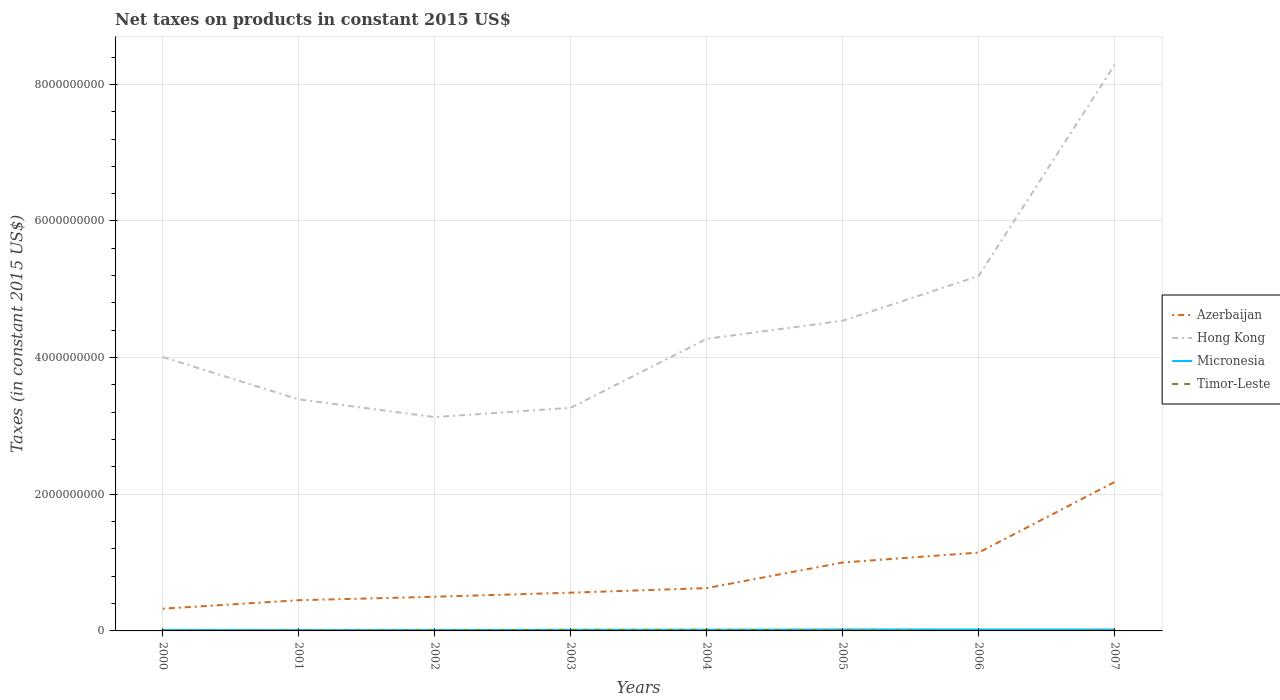How many different coloured lines are there?
Provide a succinct answer. 4. Is the number of lines equal to the number of legend labels?
Give a very brief answer. No. What is the total net taxes on products in Micronesia in the graph?
Your response must be concise. -6.44e+06. What is the difference between the highest and the second highest net taxes on products in Azerbaijan?
Keep it short and to the point. 1.85e+09. What is the difference between the highest and the lowest net taxes on products in Timor-Leste?
Your answer should be very brief. 4. Is the net taxes on products in Timor-Leste strictly greater than the net taxes on products in Hong Kong over the years?
Your answer should be compact. Yes. How many years are there in the graph?
Provide a succinct answer. 8. What is the difference between two consecutive major ticks on the Y-axis?
Provide a short and direct response. 2.00e+09. Are the values on the major ticks of Y-axis written in scientific E-notation?
Offer a terse response. No. Does the graph contain grids?
Your response must be concise. Yes. How many legend labels are there?
Provide a short and direct response. 4. What is the title of the graph?
Ensure brevity in your answer.  Net taxes on products in constant 2015 US$. What is the label or title of the Y-axis?
Keep it short and to the point. Taxes (in constant 2015 US$). What is the Taxes (in constant 2015 US$) of Azerbaijan in 2000?
Offer a terse response. 3.25e+08. What is the Taxes (in constant 2015 US$) in Hong Kong in 2000?
Make the answer very short. 4.01e+09. What is the Taxes (in constant 2015 US$) in Micronesia in 2000?
Give a very brief answer. 1.47e+07. What is the Taxes (in constant 2015 US$) of Timor-Leste in 2000?
Provide a short and direct response. 5.00e+06. What is the Taxes (in constant 2015 US$) of Azerbaijan in 2001?
Give a very brief answer. 4.49e+08. What is the Taxes (in constant 2015 US$) of Hong Kong in 2001?
Ensure brevity in your answer.  3.39e+09. What is the Taxes (in constant 2015 US$) in Micronesia in 2001?
Offer a very short reply. 1.35e+07. What is the Taxes (in constant 2015 US$) in Timor-Leste in 2001?
Keep it short and to the point. 8.00e+06. What is the Taxes (in constant 2015 US$) of Azerbaijan in 2002?
Your answer should be compact. 5.00e+08. What is the Taxes (in constant 2015 US$) in Hong Kong in 2002?
Ensure brevity in your answer.  3.13e+09. What is the Taxes (in constant 2015 US$) in Micronesia in 2002?
Your answer should be compact. 1.42e+07. What is the Taxes (in constant 2015 US$) of Azerbaijan in 2003?
Ensure brevity in your answer.  5.60e+08. What is the Taxes (in constant 2015 US$) in Hong Kong in 2003?
Your response must be concise. 3.27e+09. What is the Taxes (in constant 2015 US$) of Micronesia in 2003?
Ensure brevity in your answer.  1.67e+07. What is the Taxes (in constant 2015 US$) in Timor-Leste in 2003?
Your answer should be very brief. 1.50e+07. What is the Taxes (in constant 2015 US$) in Azerbaijan in 2004?
Ensure brevity in your answer.  6.27e+08. What is the Taxes (in constant 2015 US$) of Hong Kong in 2004?
Your answer should be very brief. 4.28e+09. What is the Taxes (in constant 2015 US$) in Micronesia in 2004?
Your answer should be very brief. 1.77e+07. What is the Taxes (in constant 2015 US$) in Timor-Leste in 2004?
Offer a very short reply. 1.60e+07. What is the Taxes (in constant 2015 US$) of Azerbaijan in 2005?
Your response must be concise. 1.00e+09. What is the Taxes (in constant 2015 US$) in Hong Kong in 2005?
Ensure brevity in your answer.  4.54e+09. What is the Taxes (in constant 2015 US$) of Micronesia in 2005?
Your answer should be compact. 2.14e+07. What is the Taxes (in constant 2015 US$) in Timor-Leste in 2005?
Offer a terse response. 1.20e+07. What is the Taxes (in constant 2015 US$) in Azerbaijan in 2006?
Give a very brief answer. 1.15e+09. What is the Taxes (in constant 2015 US$) in Hong Kong in 2006?
Your answer should be compact. 5.19e+09. What is the Taxes (in constant 2015 US$) of Micronesia in 2006?
Give a very brief answer. 2.11e+07. What is the Taxes (in constant 2015 US$) in Timor-Leste in 2006?
Provide a short and direct response. 0. What is the Taxes (in constant 2015 US$) in Azerbaijan in 2007?
Your answer should be compact. 2.18e+09. What is the Taxes (in constant 2015 US$) of Hong Kong in 2007?
Provide a succinct answer. 8.28e+09. What is the Taxes (in constant 2015 US$) in Micronesia in 2007?
Ensure brevity in your answer.  2.04e+07. What is the Taxes (in constant 2015 US$) in Timor-Leste in 2007?
Your answer should be compact. 9.00e+06. Across all years, what is the maximum Taxes (in constant 2015 US$) in Azerbaijan?
Your answer should be compact. 2.18e+09. Across all years, what is the maximum Taxes (in constant 2015 US$) in Hong Kong?
Give a very brief answer. 8.28e+09. Across all years, what is the maximum Taxes (in constant 2015 US$) of Micronesia?
Give a very brief answer. 2.14e+07. Across all years, what is the maximum Taxes (in constant 2015 US$) in Timor-Leste?
Your response must be concise. 1.60e+07. Across all years, what is the minimum Taxes (in constant 2015 US$) in Azerbaijan?
Your response must be concise. 3.25e+08. Across all years, what is the minimum Taxes (in constant 2015 US$) of Hong Kong?
Offer a terse response. 3.13e+09. Across all years, what is the minimum Taxes (in constant 2015 US$) in Micronesia?
Ensure brevity in your answer.  1.35e+07. Across all years, what is the minimum Taxes (in constant 2015 US$) of Timor-Leste?
Keep it short and to the point. 0. What is the total Taxes (in constant 2015 US$) of Azerbaijan in the graph?
Provide a succinct answer. 6.79e+09. What is the total Taxes (in constant 2015 US$) of Hong Kong in the graph?
Provide a short and direct response. 3.61e+1. What is the total Taxes (in constant 2015 US$) of Micronesia in the graph?
Ensure brevity in your answer.  1.40e+08. What is the total Taxes (in constant 2015 US$) of Timor-Leste in the graph?
Make the answer very short. 7.70e+07. What is the difference between the Taxes (in constant 2015 US$) in Azerbaijan in 2000 and that in 2001?
Keep it short and to the point. -1.24e+08. What is the difference between the Taxes (in constant 2015 US$) in Hong Kong in 2000 and that in 2001?
Ensure brevity in your answer.  6.19e+08. What is the difference between the Taxes (in constant 2015 US$) of Micronesia in 2000 and that in 2001?
Your answer should be very brief. 1.18e+06. What is the difference between the Taxes (in constant 2015 US$) in Timor-Leste in 2000 and that in 2001?
Offer a very short reply. -3.00e+06. What is the difference between the Taxes (in constant 2015 US$) in Azerbaijan in 2000 and that in 2002?
Offer a very short reply. -1.75e+08. What is the difference between the Taxes (in constant 2015 US$) of Hong Kong in 2000 and that in 2002?
Your answer should be compact. 8.79e+08. What is the difference between the Taxes (in constant 2015 US$) in Micronesia in 2000 and that in 2002?
Give a very brief answer. 4.29e+05. What is the difference between the Taxes (in constant 2015 US$) in Timor-Leste in 2000 and that in 2002?
Your answer should be compact. -7.00e+06. What is the difference between the Taxes (in constant 2015 US$) in Azerbaijan in 2000 and that in 2003?
Provide a short and direct response. -2.34e+08. What is the difference between the Taxes (in constant 2015 US$) in Hong Kong in 2000 and that in 2003?
Your answer should be very brief. 7.43e+08. What is the difference between the Taxes (in constant 2015 US$) in Micronesia in 2000 and that in 2003?
Your answer should be very brief. -2.08e+06. What is the difference between the Taxes (in constant 2015 US$) of Timor-Leste in 2000 and that in 2003?
Your response must be concise. -1.00e+07. What is the difference between the Taxes (in constant 2015 US$) in Azerbaijan in 2000 and that in 2004?
Your answer should be very brief. -3.01e+08. What is the difference between the Taxes (in constant 2015 US$) of Hong Kong in 2000 and that in 2004?
Offer a very short reply. -2.67e+08. What is the difference between the Taxes (in constant 2015 US$) of Micronesia in 2000 and that in 2004?
Make the answer very short. -3.07e+06. What is the difference between the Taxes (in constant 2015 US$) of Timor-Leste in 2000 and that in 2004?
Offer a terse response. -1.10e+07. What is the difference between the Taxes (in constant 2015 US$) of Azerbaijan in 2000 and that in 2005?
Your answer should be compact. -6.76e+08. What is the difference between the Taxes (in constant 2015 US$) of Hong Kong in 2000 and that in 2005?
Offer a very short reply. -5.31e+08. What is the difference between the Taxes (in constant 2015 US$) of Micronesia in 2000 and that in 2005?
Ensure brevity in your answer.  -6.70e+06. What is the difference between the Taxes (in constant 2015 US$) in Timor-Leste in 2000 and that in 2005?
Make the answer very short. -7.00e+06. What is the difference between the Taxes (in constant 2015 US$) of Azerbaijan in 2000 and that in 2006?
Keep it short and to the point. -8.21e+08. What is the difference between the Taxes (in constant 2015 US$) of Hong Kong in 2000 and that in 2006?
Keep it short and to the point. -1.19e+09. What is the difference between the Taxes (in constant 2015 US$) of Micronesia in 2000 and that in 2006?
Give a very brief answer. -6.44e+06. What is the difference between the Taxes (in constant 2015 US$) of Azerbaijan in 2000 and that in 2007?
Provide a short and direct response. -1.85e+09. What is the difference between the Taxes (in constant 2015 US$) in Hong Kong in 2000 and that in 2007?
Ensure brevity in your answer.  -4.28e+09. What is the difference between the Taxes (in constant 2015 US$) in Micronesia in 2000 and that in 2007?
Your answer should be compact. -5.76e+06. What is the difference between the Taxes (in constant 2015 US$) in Azerbaijan in 2001 and that in 2002?
Your response must be concise. -5.09e+07. What is the difference between the Taxes (in constant 2015 US$) of Hong Kong in 2001 and that in 2002?
Your answer should be very brief. 2.60e+08. What is the difference between the Taxes (in constant 2015 US$) in Micronesia in 2001 and that in 2002?
Offer a very short reply. -7.48e+05. What is the difference between the Taxes (in constant 2015 US$) of Azerbaijan in 2001 and that in 2003?
Offer a terse response. -1.10e+08. What is the difference between the Taxes (in constant 2015 US$) of Hong Kong in 2001 and that in 2003?
Offer a terse response. 1.24e+08. What is the difference between the Taxes (in constant 2015 US$) in Micronesia in 2001 and that in 2003?
Provide a short and direct response. -3.26e+06. What is the difference between the Taxes (in constant 2015 US$) in Timor-Leste in 2001 and that in 2003?
Your answer should be very brief. -7.00e+06. What is the difference between the Taxes (in constant 2015 US$) in Azerbaijan in 2001 and that in 2004?
Provide a short and direct response. -1.77e+08. What is the difference between the Taxes (in constant 2015 US$) in Hong Kong in 2001 and that in 2004?
Your answer should be compact. -8.86e+08. What is the difference between the Taxes (in constant 2015 US$) in Micronesia in 2001 and that in 2004?
Offer a terse response. -4.25e+06. What is the difference between the Taxes (in constant 2015 US$) of Timor-Leste in 2001 and that in 2004?
Ensure brevity in your answer.  -8.00e+06. What is the difference between the Taxes (in constant 2015 US$) in Azerbaijan in 2001 and that in 2005?
Your response must be concise. -5.52e+08. What is the difference between the Taxes (in constant 2015 US$) in Hong Kong in 2001 and that in 2005?
Keep it short and to the point. -1.15e+09. What is the difference between the Taxes (in constant 2015 US$) of Micronesia in 2001 and that in 2005?
Offer a very short reply. -7.88e+06. What is the difference between the Taxes (in constant 2015 US$) of Azerbaijan in 2001 and that in 2006?
Give a very brief answer. -6.97e+08. What is the difference between the Taxes (in constant 2015 US$) in Hong Kong in 2001 and that in 2006?
Keep it short and to the point. -1.80e+09. What is the difference between the Taxes (in constant 2015 US$) of Micronesia in 2001 and that in 2006?
Offer a very short reply. -7.62e+06. What is the difference between the Taxes (in constant 2015 US$) in Azerbaijan in 2001 and that in 2007?
Give a very brief answer. -1.73e+09. What is the difference between the Taxes (in constant 2015 US$) in Hong Kong in 2001 and that in 2007?
Offer a terse response. -4.90e+09. What is the difference between the Taxes (in constant 2015 US$) in Micronesia in 2001 and that in 2007?
Ensure brevity in your answer.  -6.93e+06. What is the difference between the Taxes (in constant 2015 US$) in Azerbaijan in 2002 and that in 2003?
Make the answer very short. -5.95e+07. What is the difference between the Taxes (in constant 2015 US$) of Hong Kong in 2002 and that in 2003?
Ensure brevity in your answer.  -1.36e+08. What is the difference between the Taxes (in constant 2015 US$) of Micronesia in 2002 and that in 2003?
Provide a succinct answer. -2.51e+06. What is the difference between the Taxes (in constant 2015 US$) of Azerbaijan in 2002 and that in 2004?
Keep it short and to the point. -1.26e+08. What is the difference between the Taxes (in constant 2015 US$) in Hong Kong in 2002 and that in 2004?
Your answer should be very brief. -1.15e+09. What is the difference between the Taxes (in constant 2015 US$) of Micronesia in 2002 and that in 2004?
Make the answer very short. -3.50e+06. What is the difference between the Taxes (in constant 2015 US$) in Timor-Leste in 2002 and that in 2004?
Provide a succinct answer. -4.00e+06. What is the difference between the Taxes (in constant 2015 US$) in Azerbaijan in 2002 and that in 2005?
Provide a short and direct response. -5.01e+08. What is the difference between the Taxes (in constant 2015 US$) of Hong Kong in 2002 and that in 2005?
Your answer should be very brief. -1.41e+09. What is the difference between the Taxes (in constant 2015 US$) of Micronesia in 2002 and that in 2005?
Give a very brief answer. -7.13e+06. What is the difference between the Taxes (in constant 2015 US$) of Timor-Leste in 2002 and that in 2005?
Your answer should be very brief. 0. What is the difference between the Taxes (in constant 2015 US$) of Azerbaijan in 2002 and that in 2006?
Ensure brevity in your answer.  -6.46e+08. What is the difference between the Taxes (in constant 2015 US$) of Hong Kong in 2002 and that in 2006?
Keep it short and to the point. -2.06e+09. What is the difference between the Taxes (in constant 2015 US$) of Micronesia in 2002 and that in 2006?
Offer a very short reply. -6.87e+06. What is the difference between the Taxes (in constant 2015 US$) in Azerbaijan in 2002 and that in 2007?
Offer a very short reply. -1.68e+09. What is the difference between the Taxes (in constant 2015 US$) of Hong Kong in 2002 and that in 2007?
Your response must be concise. -5.16e+09. What is the difference between the Taxes (in constant 2015 US$) of Micronesia in 2002 and that in 2007?
Ensure brevity in your answer.  -6.18e+06. What is the difference between the Taxes (in constant 2015 US$) in Azerbaijan in 2003 and that in 2004?
Provide a short and direct response. -6.69e+07. What is the difference between the Taxes (in constant 2015 US$) in Hong Kong in 2003 and that in 2004?
Keep it short and to the point. -1.01e+09. What is the difference between the Taxes (in constant 2015 US$) in Micronesia in 2003 and that in 2004?
Make the answer very short. -9.89e+05. What is the difference between the Taxes (in constant 2015 US$) in Azerbaijan in 2003 and that in 2005?
Provide a succinct answer. -4.41e+08. What is the difference between the Taxes (in constant 2015 US$) of Hong Kong in 2003 and that in 2005?
Keep it short and to the point. -1.27e+09. What is the difference between the Taxes (in constant 2015 US$) in Micronesia in 2003 and that in 2005?
Ensure brevity in your answer.  -4.62e+06. What is the difference between the Taxes (in constant 2015 US$) of Timor-Leste in 2003 and that in 2005?
Ensure brevity in your answer.  3.00e+06. What is the difference between the Taxes (in constant 2015 US$) in Azerbaijan in 2003 and that in 2006?
Keep it short and to the point. -5.87e+08. What is the difference between the Taxes (in constant 2015 US$) of Hong Kong in 2003 and that in 2006?
Provide a short and direct response. -1.93e+09. What is the difference between the Taxes (in constant 2015 US$) of Micronesia in 2003 and that in 2006?
Your answer should be very brief. -4.36e+06. What is the difference between the Taxes (in constant 2015 US$) in Azerbaijan in 2003 and that in 2007?
Offer a very short reply. -1.62e+09. What is the difference between the Taxes (in constant 2015 US$) in Hong Kong in 2003 and that in 2007?
Ensure brevity in your answer.  -5.02e+09. What is the difference between the Taxes (in constant 2015 US$) in Micronesia in 2003 and that in 2007?
Ensure brevity in your answer.  -3.68e+06. What is the difference between the Taxes (in constant 2015 US$) of Timor-Leste in 2003 and that in 2007?
Provide a short and direct response. 6.00e+06. What is the difference between the Taxes (in constant 2015 US$) of Azerbaijan in 2004 and that in 2005?
Your response must be concise. -3.75e+08. What is the difference between the Taxes (in constant 2015 US$) of Hong Kong in 2004 and that in 2005?
Give a very brief answer. -2.64e+08. What is the difference between the Taxes (in constant 2015 US$) of Micronesia in 2004 and that in 2005?
Offer a very short reply. -3.63e+06. What is the difference between the Taxes (in constant 2015 US$) of Timor-Leste in 2004 and that in 2005?
Keep it short and to the point. 4.00e+06. What is the difference between the Taxes (in constant 2015 US$) in Azerbaijan in 2004 and that in 2006?
Keep it short and to the point. -5.20e+08. What is the difference between the Taxes (in constant 2015 US$) of Hong Kong in 2004 and that in 2006?
Offer a very short reply. -9.19e+08. What is the difference between the Taxes (in constant 2015 US$) in Micronesia in 2004 and that in 2006?
Provide a short and direct response. -3.38e+06. What is the difference between the Taxes (in constant 2015 US$) of Azerbaijan in 2004 and that in 2007?
Offer a terse response. -1.55e+09. What is the difference between the Taxes (in constant 2015 US$) of Hong Kong in 2004 and that in 2007?
Give a very brief answer. -4.01e+09. What is the difference between the Taxes (in constant 2015 US$) of Micronesia in 2004 and that in 2007?
Provide a succinct answer. -2.69e+06. What is the difference between the Taxes (in constant 2015 US$) of Timor-Leste in 2004 and that in 2007?
Your answer should be very brief. 7.00e+06. What is the difference between the Taxes (in constant 2015 US$) of Azerbaijan in 2005 and that in 2006?
Provide a succinct answer. -1.45e+08. What is the difference between the Taxes (in constant 2015 US$) of Hong Kong in 2005 and that in 2006?
Give a very brief answer. -6.55e+08. What is the difference between the Taxes (in constant 2015 US$) of Micronesia in 2005 and that in 2006?
Provide a succinct answer. 2.57e+05. What is the difference between the Taxes (in constant 2015 US$) of Azerbaijan in 2005 and that in 2007?
Provide a short and direct response. -1.18e+09. What is the difference between the Taxes (in constant 2015 US$) of Hong Kong in 2005 and that in 2007?
Offer a very short reply. -3.75e+09. What is the difference between the Taxes (in constant 2015 US$) in Micronesia in 2005 and that in 2007?
Provide a succinct answer. 9.44e+05. What is the difference between the Taxes (in constant 2015 US$) of Azerbaijan in 2006 and that in 2007?
Your answer should be compact. -1.03e+09. What is the difference between the Taxes (in constant 2015 US$) in Hong Kong in 2006 and that in 2007?
Ensure brevity in your answer.  -3.09e+09. What is the difference between the Taxes (in constant 2015 US$) of Micronesia in 2006 and that in 2007?
Your answer should be very brief. 6.88e+05. What is the difference between the Taxes (in constant 2015 US$) of Azerbaijan in 2000 and the Taxes (in constant 2015 US$) of Hong Kong in 2001?
Give a very brief answer. -3.06e+09. What is the difference between the Taxes (in constant 2015 US$) of Azerbaijan in 2000 and the Taxes (in constant 2015 US$) of Micronesia in 2001?
Keep it short and to the point. 3.12e+08. What is the difference between the Taxes (in constant 2015 US$) of Azerbaijan in 2000 and the Taxes (in constant 2015 US$) of Timor-Leste in 2001?
Offer a terse response. 3.17e+08. What is the difference between the Taxes (in constant 2015 US$) in Hong Kong in 2000 and the Taxes (in constant 2015 US$) in Micronesia in 2001?
Your response must be concise. 4.00e+09. What is the difference between the Taxes (in constant 2015 US$) of Hong Kong in 2000 and the Taxes (in constant 2015 US$) of Timor-Leste in 2001?
Your answer should be compact. 4.00e+09. What is the difference between the Taxes (in constant 2015 US$) of Micronesia in 2000 and the Taxes (in constant 2015 US$) of Timor-Leste in 2001?
Offer a very short reply. 6.66e+06. What is the difference between the Taxes (in constant 2015 US$) in Azerbaijan in 2000 and the Taxes (in constant 2015 US$) in Hong Kong in 2002?
Ensure brevity in your answer.  -2.80e+09. What is the difference between the Taxes (in constant 2015 US$) in Azerbaijan in 2000 and the Taxes (in constant 2015 US$) in Micronesia in 2002?
Ensure brevity in your answer.  3.11e+08. What is the difference between the Taxes (in constant 2015 US$) of Azerbaijan in 2000 and the Taxes (in constant 2015 US$) of Timor-Leste in 2002?
Your answer should be compact. 3.13e+08. What is the difference between the Taxes (in constant 2015 US$) of Hong Kong in 2000 and the Taxes (in constant 2015 US$) of Micronesia in 2002?
Keep it short and to the point. 3.99e+09. What is the difference between the Taxes (in constant 2015 US$) of Hong Kong in 2000 and the Taxes (in constant 2015 US$) of Timor-Leste in 2002?
Ensure brevity in your answer.  4.00e+09. What is the difference between the Taxes (in constant 2015 US$) in Micronesia in 2000 and the Taxes (in constant 2015 US$) in Timor-Leste in 2002?
Offer a terse response. 2.66e+06. What is the difference between the Taxes (in constant 2015 US$) of Azerbaijan in 2000 and the Taxes (in constant 2015 US$) of Hong Kong in 2003?
Your answer should be compact. -2.94e+09. What is the difference between the Taxes (in constant 2015 US$) in Azerbaijan in 2000 and the Taxes (in constant 2015 US$) in Micronesia in 2003?
Provide a short and direct response. 3.09e+08. What is the difference between the Taxes (in constant 2015 US$) of Azerbaijan in 2000 and the Taxes (in constant 2015 US$) of Timor-Leste in 2003?
Your answer should be compact. 3.10e+08. What is the difference between the Taxes (in constant 2015 US$) in Hong Kong in 2000 and the Taxes (in constant 2015 US$) in Micronesia in 2003?
Provide a succinct answer. 3.99e+09. What is the difference between the Taxes (in constant 2015 US$) in Hong Kong in 2000 and the Taxes (in constant 2015 US$) in Timor-Leste in 2003?
Ensure brevity in your answer.  3.99e+09. What is the difference between the Taxes (in constant 2015 US$) in Micronesia in 2000 and the Taxes (in constant 2015 US$) in Timor-Leste in 2003?
Give a very brief answer. -3.44e+05. What is the difference between the Taxes (in constant 2015 US$) of Azerbaijan in 2000 and the Taxes (in constant 2015 US$) of Hong Kong in 2004?
Make the answer very short. -3.95e+09. What is the difference between the Taxes (in constant 2015 US$) in Azerbaijan in 2000 and the Taxes (in constant 2015 US$) in Micronesia in 2004?
Offer a very short reply. 3.08e+08. What is the difference between the Taxes (in constant 2015 US$) of Azerbaijan in 2000 and the Taxes (in constant 2015 US$) of Timor-Leste in 2004?
Offer a terse response. 3.09e+08. What is the difference between the Taxes (in constant 2015 US$) in Hong Kong in 2000 and the Taxes (in constant 2015 US$) in Micronesia in 2004?
Your response must be concise. 3.99e+09. What is the difference between the Taxes (in constant 2015 US$) of Hong Kong in 2000 and the Taxes (in constant 2015 US$) of Timor-Leste in 2004?
Your response must be concise. 3.99e+09. What is the difference between the Taxes (in constant 2015 US$) of Micronesia in 2000 and the Taxes (in constant 2015 US$) of Timor-Leste in 2004?
Ensure brevity in your answer.  -1.34e+06. What is the difference between the Taxes (in constant 2015 US$) in Azerbaijan in 2000 and the Taxes (in constant 2015 US$) in Hong Kong in 2005?
Offer a very short reply. -4.21e+09. What is the difference between the Taxes (in constant 2015 US$) of Azerbaijan in 2000 and the Taxes (in constant 2015 US$) of Micronesia in 2005?
Offer a terse response. 3.04e+08. What is the difference between the Taxes (in constant 2015 US$) of Azerbaijan in 2000 and the Taxes (in constant 2015 US$) of Timor-Leste in 2005?
Your answer should be very brief. 3.13e+08. What is the difference between the Taxes (in constant 2015 US$) of Hong Kong in 2000 and the Taxes (in constant 2015 US$) of Micronesia in 2005?
Your answer should be very brief. 3.99e+09. What is the difference between the Taxes (in constant 2015 US$) of Hong Kong in 2000 and the Taxes (in constant 2015 US$) of Timor-Leste in 2005?
Offer a very short reply. 4.00e+09. What is the difference between the Taxes (in constant 2015 US$) in Micronesia in 2000 and the Taxes (in constant 2015 US$) in Timor-Leste in 2005?
Keep it short and to the point. 2.66e+06. What is the difference between the Taxes (in constant 2015 US$) of Azerbaijan in 2000 and the Taxes (in constant 2015 US$) of Hong Kong in 2006?
Ensure brevity in your answer.  -4.87e+09. What is the difference between the Taxes (in constant 2015 US$) in Azerbaijan in 2000 and the Taxes (in constant 2015 US$) in Micronesia in 2006?
Give a very brief answer. 3.04e+08. What is the difference between the Taxes (in constant 2015 US$) in Hong Kong in 2000 and the Taxes (in constant 2015 US$) in Micronesia in 2006?
Give a very brief answer. 3.99e+09. What is the difference between the Taxes (in constant 2015 US$) in Azerbaijan in 2000 and the Taxes (in constant 2015 US$) in Hong Kong in 2007?
Your answer should be very brief. -7.96e+09. What is the difference between the Taxes (in constant 2015 US$) of Azerbaijan in 2000 and the Taxes (in constant 2015 US$) of Micronesia in 2007?
Make the answer very short. 3.05e+08. What is the difference between the Taxes (in constant 2015 US$) in Azerbaijan in 2000 and the Taxes (in constant 2015 US$) in Timor-Leste in 2007?
Ensure brevity in your answer.  3.16e+08. What is the difference between the Taxes (in constant 2015 US$) in Hong Kong in 2000 and the Taxes (in constant 2015 US$) in Micronesia in 2007?
Provide a succinct answer. 3.99e+09. What is the difference between the Taxes (in constant 2015 US$) in Hong Kong in 2000 and the Taxes (in constant 2015 US$) in Timor-Leste in 2007?
Keep it short and to the point. 4.00e+09. What is the difference between the Taxes (in constant 2015 US$) in Micronesia in 2000 and the Taxes (in constant 2015 US$) in Timor-Leste in 2007?
Make the answer very short. 5.66e+06. What is the difference between the Taxes (in constant 2015 US$) of Azerbaijan in 2001 and the Taxes (in constant 2015 US$) of Hong Kong in 2002?
Provide a succinct answer. -2.68e+09. What is the difference between the Taxes (in constant 2015 US$) in Azerbaijan in 2001 and the Taxes (in constant 2015 US$) in Micronesia in 2002?
Offer a terse response. 4.35e+08. What is the difference between the Taxes (in constant 2015 US$) of Azerbaijan in 2001 and the Taxes (in constant 2015 US$) of Timor-Leste in 2002?
Offer a terse response. 4.37e+08. What is the difference between the Taxes (in constant 2015 US$) in Hong Kong in 2001 and the Taxes (in constant 2015 US$) in Micronesia in 2002?
Offer a terse response. 3.38e+09. What is the difference between the Taxes (in constant 2015 US$) of Hong Kong in 2001 and the Taxes (in constant 2015 US$) of Timor-Leste in 2002?
Make the answer very short. 3.38e+09. What is the difference between the Taxes (in constant 2015 US$) in Micronesia in 2001 and the Taxes (in constant 2015 US$) in Timor-Leste in 2002?
Offer a terse response. 1.48e+06. What is the difference between the Taxes (in constant 2015 US$) of Azerbaijan in 2001 and the Taxes (in constant 2015 US$) of Hong Kong in 2003?
Your response must be concise. -2.82e+09. What is the difference between the Taxes (in constant 2015 US$) in Azerbaijan in 2001 and the Taxes (in constant 2015 US$) in Micronesia in 2003?
Offer a very short reply. 4.33e+08. What is the difference between the Taxes (in constant 2015 US$) of Azerbaijan in 2001 and the Taxes (in constant 2015 US$) of Timor-Leste in 2003?
Give a very brief answer. 4.34e+08. What is the difference between the Taxes (in constant 2015 US$) of Hong Kong in 2001 and the Taxes (in constant 2015 US$) of Micronesia in 2003?
Keep it short and to the point. 3.37e+09. What is the difference between the Taxes (in constant 2015 US$) in Hong Kong in 2001 and the Taxes (in constant 2015 US$) in Timor-Leste in 2003?
Your answer should be very brief. 3.37e+09. What is the difference between the Taxes (in constant 2015 US$) of Micronesia in 2001 and the Taxes (in constant 2015 US$) of Timor-Leste in 2003?
Provide a succinct answer. -1.52e+06. What is the difference between the Taxes (in constant 2015 US$) of Azerbaijan in 2001 and the Taxes (in constant 2015 US$) of Hong Kong in 2004?
Offer a very short reply. -3.83e+09. What is the difference between the Taxes (in constant 2015 US$) in Azerbaijan in 2001 and the Taxes (in constant 2015 US$) in Micronesia in 2004?
Your answer should be very brief. 4.32e+08. What is the difference between the Taxes (in constant 2015 US$) in Azerbaijan in 2001 and the Taxes (in constant 2015 US$) in Timor-Leste in 2004?
Give a very brief answer. 4.33e+08. What is the difference between the Taxes (in constant 2015 US$) in Hong Kong in 2001 and the Taxes (in constant 2015 US$) in Micronesia in 2004?
Offer a very short reply. 3.37e+09. What is the difference between the Taxes (in constant 2015 US$) in Hong Kong in 2001 and the Taxes (in constant 2015 US$) in Timor-Leste in 2004?
Make the answer very short. 3.37e+09. What is the difference between the Taxes (in constant 2015 US$) in Micronesia in 2001 and the Taxes (in constant 2015 US$) in Timor-Leste in 2004?
Offer a terse response. -2.52e+06. What is the difference between the Taxes (in constant 2015 US$) of Azerbaijan in 2001 and the Taxes (in constant 2015 US$) of Hong Kong in 2005?
Your answer should be compact. -4.09e+09. What is the difference between the Taxes (in constant 2015 US$) in Azerbaijan in 2001 and the Taxes (in constant 2015 US$) in Micronesia in 2005?
Your response must be concise. 4.28e+08. What is the difference between the Taxes (in constant 2015 US$) of Azerbaijan in 2001 and the Taxes (in constant 2015 US$) of Timor-Leste in 2005?
Offer a very short reply. 4.37e+08. What is the difference between the Taxes (in constant 2015 US$) in Hong Kong in 2001 and the Taxes (in constant 2015 US$) in Micronesia in 2005?
Your answer should be compact. 3.37e+09. What is the difference between the Taxes (in constant 2015 US$) in Hong Kong in 2001 and the Taxes (in constant 2015 US$) in Timor-Leste in 2005?
Your response must be concise. 3.38e+09. What is the difference between the Taxes (in constant 2015 US$) in Micronesia in 2001 and the Taxes (in constant 2015 US$) in Timor-Leste in 2005?
Make the answer very short. 1.48e+06. What is the difference between the Taxes (in constant 2015 US$) in Azerbaijan in 2001 and the Taxes (in constant 2015 US$) in Hong Kong in 2006?
Provide a succinct answer. -4.75e+09. What is the difference between the Taxes (in constant 2015 US$) in Azerbaijan in 2001 and the Taxes (in constant 2015 US$) in Micronesia in 2006?
Provide a succinct answer. 4.28e+08. What is the difference between the Taxes (in constant 2015 US$) in Hong Kong in 2001 and the Taxes (in constant 2015 US$) in Micronesia in 2006?
Your response must be concise. 3.37e+09. What is the difference between the Taxes (in constant 2015 US$) of Azerbaijan in 2001 and the Taxes (in constant 2015 US$) of Hong Kong in 2007?
Your answer should be very brief. -7.84e+09. What is the difference between the Taxes (in constant 2015 US$) of Azerbaijan in 2001 and the Taxes (in constant 2015 US$) of Micronesia in 2007?
Give a very brief answer. 4.29e+08. What is the difference between the Taxes (in constant 2015 US$) in Azerbaijan in 2001 and the Taxes (in constant 2015 US$) in Timor-Leste in 2007?
Keep it short and to the point. 4.40e+08. What is the difference between the Taxes (in constant 2015 US$) in Hong Kong in 2001 and the Taxes (in constant 2015 US$) in Micronesia in 2007?
Your answer should be compact. 3.37e+09. What is the difference between the Taxes (in constant 2015 US$) in Hong Kong in 2001 and the Taxes (in constant 2015 US$) in Timor-Leste in 2007?
Offer a very short reply. 3.38e+09. What is the difference between the Taxes (in constant 2015 US$) in Micronesia in 2001 and the Taxes (in constant 2015 US$) in Timor-Leste in 2007?
Provide a succinct answer. 4.48e+06. What is the difference between the Taxes (in constant 2015 US$) of Azerbaijan in 2002 and the Taxes (in constant 2015 US$) of Hong Kong in 2003?
Your answer should be compact. -2.77e+09. What is the difference between the Taxes (in constant 2015 US$) of Azerbaijan in 2002 and the Taxes (in constant 2015 US$) of Micronesia in 2003?
Offer a very short reply. 4.83e+08. What is the difference between the Taxes (in constant 2015 US$) of Azerbaijan in 2002 and the Taxes (in constant 2015 US$) of Timor-Leste in 2003?
Your response must be concise. 4.85e+08. What is the difference between the Taxes (in constant 2015 US$) in Hong Kong in 2002 and the Taxes (in constant 2015 US$) in Micronesia in 2003?
Offer a very short reply. 3.11e+09. What is the difference between the Taxes (in constant 2015 US$) in Hong Kong in 2002 and the Taxes (in constant 2015 US$) in Timor-Leste in 2003?
Ensure brevity in your answer.  3.11e+09. What is the difference between the Taxes (in constant 2015 US$) in Micronesia in 2002 and the Taxes (in constant 2015 US$) in Timor-Leste in 2003?
Make the answer very short. -7.73e+05. What is the difference between the Taxes (in constant 2015 US$) of Azerbaijan in 2002 and the Taxes (in constant 2015 US$) of Hong Kong in 2004?
Offer a very short reply. -3.78e+09. What is the difference between the Taxes (in constant 2015 US$) of Azerbaijan in 2002 and the Taxes (in constant 2015 US$) of Micronesia in 2004?
Give a very brief answer. 4.82e+08. What is the difference between the Taxes (in constant 2015 US$) in Azerbaijan in 2002 and the Taxes (in constant 2015 US$) in Timor-Leste in 2004?
Make the answer very short. 4.84e+08. What is the difference between the Taxes (in constant 2015 US$) of Hong Kong in 2002 and the Taxes (in constant 2015 US$) of Micronesia in 2004?
Your answer should be very brief. 3.11e+09. What is the difference between the Taxes (in constant 2015 US$) of Hong Kong in 2002 and the Taxes (in constant 2015 US$) of Timor-Leste in 2004?
Offer a very short reply. 3.11e+09. What is the difference between the Taxes (in constant 2015 US$) of Micronesia in 2002 and the Taxes (in constant 2015 US$) of Timor-Leste in 2004?
Give a very brief answer. -1.77e+06. What is the difference between the Taxes (in constant 2015 US$) of Azerbaijan in 2002 and the Taxes (in constant 2015 US$) of Hong Kong in 2005?
Keep it short and to the point. -4.04e+09. What is the difference between the Taxes (in constant 2015 US$) of Azerbaijan in 2002 and the Taxes (in constant 2015 US$) of Micronesia in 2005?
Ensure brevity in your answer.  4.79e+08. What is the difference between the Taxes (in constant 2015 US$) in Azerbaijan in 2002 and the Taxes (in constant 2015 US$) in Timor-Leste in 2005?
Your response must be concise. 4.88e+08. What is the difference between the Taxes (in constant 2015 US$) of Hong Kong in 2002 and the Taxes (in constant 2015 US$) of Micronesia in 2005?
Your answer should be very brief. 3.11e+09. What is the difference between the Taxes (in constant 2015 US$) of Hong Kong in 2002 and the Taxes (in constant 2015 US$) of Timor-Leste in 2005?
Your answer should be very brief. 3.12e+09. What is the difference between the Taxes (in constant 2015 US$) in Micronesia in 2002 and the Taxes (in constant 2015 US$) in Timor-Leste in 2005?
Your answer should be compact. 2.23e+06. What is the difference between the Taxes (in constant 2015 US$) in Azerbaijan in 2002 and the Taxes (in constant 2015 US$) in Hong Kong in 2006?
Offer a very short reply. -4.69e+09. What is the difference between the Taxes (in constant 2015 US$) in Azerbaijan in 2002 and the Taxes (in constant 2015 US$) in Micronesia in 2006?
Give a very brief answer. 4.79e+08. What is the difference between the Taxes (in constant 2015 US$) in Hong Kong in 2002 and the Taxes (in constant 2015 US$) in Micronesia in 2006?
Offer a very short reply. 3.11e+09. What is the difference between the Taxes (in constant 2015 US$) of Azerbaijan in 2002 and the Taxes (in constant 2015 US$) of Hong Kong in 2007?
Provide a short and direct response. -7.78e+09. What is the difference between the Taxes (in constant 2015 US$) in Azerbaijan in 2002 and the Taxes (in constant 2015 US$) in Micronesia in 2007?
Your answer should be very brief. 4.80e+08. What is the difference between the Taxes (in constant 2015 US$) of Azerbaijan in 2002 and the Taxes (in constant 2015 US$) of Timor-Leste in 2007?
Your answer should be compact. 4.91e+08. What is the difference between the Taxes (in constant 2015 US$) in Hong Kong in 2002 and the Taxes (in constant 2015 US$) in Micronesia in 2007?
Your answer should be very brief. 3.11e+09. What is the difference between the Taxes (in constant 2015 US$) of Hong Kong in 2002 and the Taxes (in constant 2015 US$) of Timor-Leste in 2007?
Your answer should be compact. 3.12e+09. What is the difference between the Taxes (in constant 2015 US$) of Micronesia in 2002 and the Taxes (in constant 2015 US$) of Timor-Leste in 2007?
Your response must be concise. 5.23e+06. What is the difference between the Taxes (in constant 2015 US$) of Azerbaijan in 2003 and the Taxes (in constant 2015 US$) of Hong Kong in 2004?
Make the answer very short. -3.72e+09. What is the difference between the Taxes (in constant 2015 US$) of Azerbaijan in 2003 and the Taxes (in constant 2015 US$) of Micronesia in 2004?
Keep it short and to the point. 5.42e+08. What is the difference between the Taxes (in constant 2015 US$) in Azerbaijan in 2003 and the Taxes (in constant 2015 US$) in Timor-Leste in 2004?
Offer a very short reply. 5.44e+08. What is the difference between the Taxes (in constant 2015 US$) in Hong Kong in 2003 and the Taxes (in constant 2015 US$) in Micronesia in 2004?
Provide a succinct answer. 3.25e+09. What is the difference between the Taxes (in constant 2015 US$) of Hong Kong in 2003 and the Taxes (in constant 2015 US$) of Timor-Leste in 2004?
Your response must be concise. 3.25e+09. What is the difference between the Taxes (in constant 2015 US$) of Micronesia in 2003 and the Taxes (in constant 2015 US$) of Timor-Leste in 2004?
Your response must be concise. 7.35e+05. What is the difference between the Taxes (in constant 2015 US$) of Azerbaijan in 2003 and the Taxes (in constant 2015 US$) of Hong Kong in 2005?
Your answer should be compact. -3.98e+09. What is the difference between the Taxes (in constant 2015 US$) of Azerbaijan in 2003 and the Taxes (in constant 2015 US$) of Micronesia in 2005?
Your answer should be very brief. 5.38e+08. What is the difference between the Taxes (in constant 2015 US$) in Azerbaijan in 2003 and the Taxes (in constant 2015 US$) in Timor-Leste in 2005?
Your answer should be compact. 5.48e+08. What is the difference between the Taxes (in constant 2015 US$) in Hong Kong in 2003 and the Taxes (in constant 2015 US$) in Micronesia in 2005?
Provide a succinct answer. 3.24e+09. What is the difference between the Taxes (in constant 2015 US$) of Hong Kong in 2003 and the Taxes (in constant 2015 US$) of Timor-Leste in 2005?
Make the answer very short. 3.25e+09. What is the difference between the Taxes (in constant 2015 US$) of Micronesia in 2003 and the Taxes (in constant 2015 US$) of Timor-Leste in 2005?
Your answer should be compact. 4.73e+06. What is the difference between the Taxes (in constant 2015 US$) of Azerbaijan in 2003 and the Taxes (in constant 2015 US$) of Hong Kong in 2006?
Your response must be concise. -4.63e+09. What is the difference between the Taxes (in constant 2015 US$) in Azerbaijan in 2003 and the Taxes (in constant 2015 US$) in Micronesia in 2006?
Your answer should be very brief. 5.39e+08. What is the difference between the Taxes (in constant 2015 US$) of Hong Kong in 2003 and the Taxes (in constant 2015 US$) of Micronesia in 2006?
Your answer should be very brief. 3.24e+09. What is the difference between the Taxes (in constant 2015 US$) in Azerbaijan in 2003 and the Taxes (in constant 2015 US$) in Hong Kong in 2007?
Provide a succinct answer. -7.73e+09. What is the difference between the Taxes (in constant 2015 US$) of Azerbaijan in 2003 and the Taxes (in constant 2015 US$) of Micronesia in 2007?
Your answer should be very brief. 5.39e+08. What is the difference between the Taxes (in constant 2015 US$) of Azerbaijan in 2003 and the Taxes (in constant 2015 US$) of Timor-Leste in 2007?
Your answer should be very brief. 5.51e+08. What is the difference between the Taxes (in constant 2015 US$) in Hong Kong in 2003 and the Taxes (in constant 2015 US$) in Micronesia in 2007?
Keep it short and to the point. 3.25e+09. What is the difference between the Taxes (in constant 2015 US$) of Hong Kong in 2003 and the Taxes (in constant 2015 US$) of Timor-Leste in 2007?
Your answer should be compact. 3.26e+09. What is the difference between the Taxes (in constant 2015 US$) of Micronesia in 2003 and the Taxes (in constant 2015 US$) of Timor-Leste in 2007?
Provide a short and direct response. 7.73e+06. What is the difference between the Taxes (in constant 2015 US$) of Azerbaijan in 2004 and the Taxes (in constant 2015 US$) of Hong Kong in 2005?
Give a very brief answer. -3.91e+09. What is the difference between the Taxes (in constant 2015 US$) in Azerbaijan in 2004 and the Taxes (in constant 2015 US$) in Micronesia in 2005?
Offer a terse response. 6.05e+08. What is the difference between the Taxes (in constant 2015 US$) of Azerbaijan in 2004 and the Taxes (in constant 2015 US$) of Timor-Leste in 2005?
Provide a short and direct response. 6.15e+08. What is the difference between the Taxes (in constant 2015 US$) in Hong Kong in 2004 and the Taxes (in constant 2015 US$) in Micronesia in 2005?
Offer a terse response. 4.25e+09. What is the difference between the Taxes (in constant 2015 US$) in Hong Kong in 2004 and the Taxes (in constant 2015 US$) in Timor-Leste in 2005?
Provide a short and direct response. 4.26e+09. What is the difference between the Taxes (in constant 2015 US$) of Micronesia in 2004 and the Taxes (in constant 2015 US$) of Timor-Leste in 2005?
Give a very brief answer. 5.72e+06. What is the difference between the Taxes (in constant 2015 US$) of Azerbaijan in 2004 and the Taxes (in constant 2015 US$) of Hong Kong in 2006?
Your answer should be very brief. -4.57e+09. What is the difference between the Taxes (in constant 2015 US$) in Azerbaijan in 2004 and the Taxes (in constant 2015 US$) in Micronesia in 2006?
Ensure brevity in your answer.  6.05e+08. What is the difference between the Taxes (in constant 2015 US$) of Hong Kong in 2004 and the Taxes (in constant 2015 US$) of Micronesia in 2006?
Provide a succinct answer. 4.25e+09. What is the difference between the Taxes (in constant 2015 US$) of Azerbaijan in 2004 and the Taxes (in constant 2015 US$) of Hong Kong in 2007?
Keep it short and to the point. -7.66e+09. What is the difference between the Taxes (in constant 2015 US$) in Azerbaijan in 2004 and the Taxes (in constant 2015 US$) in Micronesia in 2007?
Provide a succinct answer. 6.06e+08. What is the difference between the Taxes (in constant 2015 US$) of Azerbaijan in 2004 and the Taxes (in constant 2015 US$) of Timor-Leste in 2007?
Ensure brevity in your answer.  6.18e+08. What is the difference between the Taxes (in constant 2015 US$) of Hong Kong in 2004 and the Taxes (in constant 2015 US$) of Micronesia in 2007?
Your answer should be compact. 4.25e+09. What is the difference between the Taxes (in constant 2015 US$) in Hong Kong in 2004 and the Taxes (in constant 2015 US$) in Timor-Leste in 2007?
Keep it short and to the point. 4.27e+09. What is the difference between the Taxes (in constant 2015 US$) in Micronesia in 2004 and the Taxes (in constant 2015 US$) in Timor-Leste in 2007?
Your response must be concise. 8.72e+06. What is the difference between the Taxes (in constant 2015 US$) in Azerbaijan in 2005 and the Taxes (in constant 2015 US$) in Hong Kong in 2006?
Provide a short and direct response. -4.19e+09. What is the difference between the Taxes (in constant 2015 US$) of Azerbaijan in 2005 and the Taxes (in constant 2015 US$) of Micronesia in 2006?
Keep it short and to the point. 9.80e+08. What is the difference between the Taxes (in constant 2015 US$) of Hong Kong in 2005 and the Taxes (in constant 2015 US$) of Micronesia in 2006?
Your answer should be very brief. 4.52e+09. What is the difference between the Taxes (in constant 2015 US$) of Azerbaijan in 2005 and the Taxes (in constant 2015 US$) of Hong Kong in 2007?
Offer a terse response. -7.28e+09. What is the difference between the Taxes (in constant 2015 US$) in Azerbaijan in 2005 and the Taxes (in constant 2015 US$) in Micronesia in 2007?
Ensure brevity in your answer.  9.81e+08. What is the difference between the Taxes (in constant 2015 US$) of Azerbaijan in 2005 and the Taxes (in constant 2015 US$) of Timor-Leste in 2007?
Ensure brevity in your answer.  9.92e+08. What is the difference between the Taxes (in constant 2015 US$) of Hong Kong in 2005 and the Taxes (in constant 2015 US$) of Micronesia in 2007?
Your response must be concise. 4.52e+09. What is the difference between the Taxes (in constant 2015 US$) of Hong Kong in 2005 and the Taxes (in constant 2015 US$) of Timor-Leste in 2007?
Ensure brevity in your answer.  4.53e+09. What is the difference between the Taxes (in constant 2015 US$) in Micronesia in 2005 and the Taxes (in constant 2015 US$) in Timor-Leste in 2007?
Make the answer very short. 1.24e+07. What is the difference between the Taxes (in constant 2015 US$) of Azerbaijan in 2006 and the Taxes (in constant 2015 US$) of Hong Kong in 2007?
Make the answer very short. -7.14e+09. What is the difference between the Taxes (in constant 2015 US$) of Azerbaijan in 2006 and the Taxes (in constant 2015 US$) of Micronesia in 2007?
Ensure brevity in your answer.  1.13e+09. What is the difference between the Taxes (in constant 2015 US$) of Azerbaijan in 2006 and the Taxes (in constant 2015 US$) of Timor-Leste in 2007?
Provide a succinct answer. 1.14e+09. What is the difference between the Taxes (in constant 2015 US$) of Hong Kong in 2006 and the Taxes (in constant 2015 US$) of Micronesia in 2007?
Keep it short and to the point. 5.17e+09. What is the difference between the Taxes (in constant 2015 US$) of Hong Kong in 2006 and the Taxes (in constant 2015 US$) of Timor-Leste in 2007?
Provide a short and direct response. 5.19e+09. What is the difference between the Taxes (in constant 2015 US$) of Micronesia in 2006 and the Taxes (in constant 2015 US$) of Timor-Leste in 2007?
Make the answer very short. 1.21e+07. What is the average Taxes (in constant 2015 US$) of Azerbaijan per year?
Provide a short and direct response. 8.49e+08. What is the average Taxes (in constant 2015 US$) of Hong Kong per year?
Offer a terse response. 4.51e+09. What is the average Taxes (in constant 2015 US$) of Micronesia per year?
Your answer should be very brief. 1.75e+07. What is the average Taxes (in constant 2015 US$) in Timor-Leste per year?
Make the answer very short. 9.62e+06. In the year 2000, what is the difference between the Taxes (in constant 2015 US$) of Azerbaijan and Taxes (in constant 2015 US$) of Hong Kong?
Ensure brevity in your answer.  -3.68e+09. In the year 2000, what is the difference between the Taxes (in constant 2015 US$) of Azerbaijan and Taxes (in constant 2015 US$) of Micronesia?
Your answer should be compact. 3.11e+08. In the year 2000, what is the difference between the Taxes (in constant 2015 US$) of Azerbaijan and Taxes (in constant 2015 US$) of Timor-Leste?
Ensure brevity in your answer.  3.20e+08. In the year 2000, what is the difference between the Taxes (in constant 2015 US$) of Hong Kong and Taxes (in constant 2015 US$) of Micronesia?
Offer a terse response. 3.99e+09. In the year 2000, what is the difference between the Taxes (in constant 2015 US$) in Hong Kong and Taxes (in constant 2015 US$) in Timor-Leste?
Offer a very short reply. 4.00e+09. In the year 2000, what is the difference between the Taxes (in constant 2015 US$) of Micronesia and Taxes (in constant 2015 US$) of Timor-Leste?
Provide a succinct answer. 9.66e+06. In the year 2001, what is the difference between the Taxes (in constant 2015 US$) in Azerbaijan and Taxes (in constant 2015 US$) in Hong Kong?
Ensure brevity in your answer.  -2.94e+09. In the year 2001, what is the difference between the Taxes (in constant 2015 US$) in Azerbaijan and Taxes (in constant 2015 US$) in Micronesia?
Give a very brief answer. 4.36e+08. In the year 2001, what is the difference between the Taxes (in constant 2015 US$) of Azerbaijan and Taxes (in constant 2015 US$) of Timor-Leste?
Provide a succinct answer. 4.41e+08. In the year 2001, what is the difference between the Taxes (in constant 2015 US$) of Hong Kong and Taxes (in constant 2015 US$) of Micronesia?
Provide a short and direct response. 3.38e+09. In the year 2001, what is the difference between the Taxes (in constant 2015 US$) in Hong Kong and Taxes (in constant 2015 US$) in Timor-Leste?
Ensure brevity in your answer.  3.38e+09. In the year 2001, what is the difference between the Taxes (in constant 2015 US$) in Micronesia and Taxes (in constant 2015 US$) in Timor-Leste?
Your answer should be very brief. 5.48e+06. In the year 2002, what is the difference between the Taxes (in constant 2015 US$) of Azerbaijan and Taxes (in constant 2015 US$) of Hong Kong?
Your answer should be compact. -2.63e+09. In the year 2002, what is the difference between the Taxes (in constant 2015 US$) of Azerbaijan and Taxes (in constant 2015 US$) of Micronesia?
Offer a terse response. 4.86e+08. In the year 2002, what is the difference between the Taxes (in constant 2015 US$) in Azerbaijan and Taxes (in constant 2015 US$) in Timor-Leste?
Offer a terse response. 4.88e+08. In the year 2002, what is the difference between the Taxes (in constant 2015 US$) in Hong Kong and Taxes (in constant 2015 US$) in Micronesia?
Provide a short and direct response. 3.12e+09. In the year 2002, what is the difference between the Taxes (in constant 2015 US$) in Hong Kong and Taxes (in constant 2015 US$) in Timor-Leste?
Your answer should be very brief. 3.12e+09. In the year 2002, what is the difference between the Taxes (in constant 2015 US$) of Micronesia and Taxes (in constant 2015 US$) of Timor-Leste?
Your answer should be compact. 2.23e+06. In the year 2003, what is the difference between the Taxes (in constant 2015 US$) of Azerbaijan and Taxes (in constant 2015 US$) of Hong Kong?
Offer a very short reply. -2.71e+09. In the year 2003, what is the difference between the Taxes (in constant 2015 US$) in Azerbaijan and Taxes (in constant 2015 US$) in Micronesia?
Your response must be concise. 5.43e+08. In the year 2003, what is the difference between the Taxes (in constant 2015 US$) of Azerbaijan and Taxes (in constant 2015 US$) of Timor-Leste?
Offer a terse response. 5.45e+08. In the year 2003, what is the difference between the Taxes (in constant 2015 US$) in Hong Kong and Taxes (in constant 2015 US$) in Micronesia?
Your answer should be compact. 3.25e+09. In the year 2003, what is the difference between the Taxes (in constant 2015 US$) in Hong Kong and Taxes (in constant 2015 US$) in Timor-Leste?
Make the answer very short. 3.25e+09. In the year 2003, what is the difference between the Taxes (in constant 2015 US$) of Micronesia and Taxes (in constant 2015 US$) of Timor-Leste?
Offer a terse response. 1.73e+06. In the year 2004, what is the difference between the Taxes (in constant 2015 US$) of Azerbaijan and Taxes (in constant 2015 US$) of Hong Kong?
Provide a succinct answer. -3.65e+09. In the year 2004, what is the difference between the Taxes (in constant 2015 US$) in Azerbaijan and Taxes (in constant 2015 US$) in Micronesia?
Offer a terse response. 6.09e+08. In the year 2004, what is the difference between the Taxes (in constant 2015 US$) in Azerbaijan and Taxes (in constant 2015 US$) in Timor-Leste?
Provide a succinct answer. 6.11e+08. In the year 2004, what is the difference between the Taxes (in constant 2015 US$) of Hong Kong and Taxes (in constant 2015 US$) of Micronesia?
Ensure brevity in your answer.  4.26e+09. In the year 2004, what is the difference between the Taxes (in constant 2015 US$) of Hong Kong and Taxes (in constant 2015 US$) of Timor-Leste?
Ensure brevity in your answer.  4.26e+09. In the year 2004, what is the difference between the Taxes (in constant 2015 US$) in Micronesia and Taxes (in constant 2015 US$) in Timor-Leste?
Keep it short and to the point. 1.72e+06. In the year 2005, what is the difference between the Taxes (in constant 2015 US$) in Azerbaijan and Taxes (in constant 2015 US$) in Hong Kong?
Make the answer very short. -3.54e+09. In the year 2005, what is the difference between the Taxes (in constant 2015 US$) of Azerbaijan and Taxes (in constant 2015 US$) of Micronesia?
Make the answer very short. 9.80e+08. In the year 2005, what is the difference between the Taxes (in constant 2015 US$) in Azerbaijan and Taxes (in constant 2015 US$) in Timor-Leste?
Offer a terse response. 9.89e+08. In the year 2005, what is the difference between the Taxes (in constant 2015 US$) of Hong Kong and Taxes (in constant 2015 US$) of Micronesia?
Make the answer very short. 4.52e+09. In the year 2005, what is the difference between the Taxes (in constant 2015 US$) of Hong Kong and Taxes (in constant 2015 US$) of Timor-Leste?
Your answer should be very brief. 4.53e+09. In the year 2005, what is the difference between the Taxes (in constant 2015 US$) in Micronesia and Taxes (in constant 2015 US$) in Timor-Leste?
Offer a terse response. 9.36e+06. In the year 2006, what is the difference between the Taxes (in constant 2015 US$) in Azerbaijan and Taxes (in constant 2015 US$) in Hong Kong?
Give a very brief answer. -4.05e+09. In the year 2006, what is the difference between the Taxes (in constant 2015 US$) in Azerbaijan and Taxes (in constant 2015 US$) in Micronesia?
Give a very brief answer. 1.13e+09. In the year 2006, what is the difference between the Taxes (in constant 2015 US$) in Hong Kong and Taxes (in constant 2015 US$) in Micronesia?
Provide a short and direct response. 5.17e+09. In the year 2007, what is the difference between the Taxes (in constant 2015 US$) in Azerbaijan and Taxes (in constant 2015 US$) in Hong Kong?
Make the answer very short. -6.11e+09. In the year 2007, what is the difference between the Taxes (in constant 2015 US$) in Azerbaijan and Taxes (in constant 2015 US$) in Micronesia?
Your answer should be compact. 2.16e+09. In the year 2007, what is the difference between the Taxes (in constant 2015 US$) in Azerbaijan and Taxes (in constant 2015 US$) in Timor-Leste?
Your answer should be very brief. 2.17e+09. In the year 2007, what is the difference between the Taxes (in constant 2015 US$) of Hong Kong and Taxes (in constant 2015 US$) of Micronesia?
Keep it short and to the point. 8.26e+09. In the year 2007, what is the difference between the Taxes (in constant 2015 US$) of Hong Kong and Taxes (in constant 2015 US$) of Timor-Leste?
Give a very brief answer. 8.28e+09. In the year 2007, what is the difference between the Taxes (in constant 2015 US$) in Micronesia and Taxes (in constant 2015 US$) in Timor-Leste?
Ensure brevity in your answer.  1.14e+07. What is the ratio of the Taxes (in constant 2015 US$) of Azerbaijan in 2000 to that in 2001?
Provide a short and direct response. 0.72. What is the ratio of the Taxes (in constant 2015 US$) of Hong Kong in 2000 to that in 2001?
Your answer should be very brief. 1.18. What is the ratio of the Taxes (in constant 2015 US$) in Micronesia in 2000 to that in 2001?
Offer a terse response. 1.09. What is the ratio of the Taxes (in constant 2015 US$) of Azerbaijan in 2000 to that in 2002?
Your answer should be very brief. 0.65. What is the ratio of the Taxes (in constant 2015 US$) in Hong Kong in 2000 to that in 2002?
Your answer should be compact. 1.28. What is the ratio of the Taxes (in constant 2015 US$) of Micronesia in 2000 to that in 2002?
Offer a very short reply. 1.03. What is the ratio of the Taxes (in constant 2015 US$) of Timor-Leste in 2000 to that in 2002?
Your response must be concise. 0.42. What is the ratio of the Taxes (in constant 2015 US$) in Azerbaijan in 2000 to that in 2003?
Ensure brevity in your answer.  0.58. What is the ratio of the Taxes (in constant 2015 US$) in Hong Kong in 2000 to that in 2003?
Ensure brevity in your answer.  1.23. What is the ratio of the Taxes (in constant 2015 US$) in Micronesia in 2000 to that in 2003?
Make the answer very short. 0.88. What is the ratio of the Taxes (in constant 2015 US$) in Timor-Leste in 2000 to that in 2003?
Provide a succinct answer. 0.33. What is the ratio of the Taxes (in constant 2015 US$) in Azerbaijan in 2000 to that in 2004?
Provide a short and direct response. 0.52. What is the ratio of the Taxes (in constant 2015 US$) in Hong Kong in 2000 to that in 2004?
Provide a short and direct response. 0.94. What is the ratio of the Taxes (in constant 2015 US$) in Micronesia in 2000 to that in 2004?
Make the answer very short. 0.83. What is the ratio of the Taxes (in constant 2015 US$) in Timor-Leste in 2000 to that in 2004?
Provide a short and direct response. 0.31. What is the ratio of the Taxes (in constant 2015 US$) of Azerbaijan in 2000 to that in 2005?
Offer a very short reply. 0.33. What is the ratio of the Taxes (in constant 2015 US$) of Hong Kong in 2000 to that in 2005?
Your response must be concise. 0.88. What is the ratio of the Taxes (in constant 2015 US$) in Micronesia in 2000 to that in 2005?
Provide a short and direct response. 0.69. What is the ratio of the Taxes (in constant 2015 US$) of Timor-Leste in 2000 to that in 2005?
Give a very brief answer. 0.42. What is the ratio of the Taxes (in constant 2015 US$) in Azerbaijan in 2000 to that in 2006?
Provide a succinct answer. 0.28. What is the ratio of the Taxes (in constant 2015 US$) in Hong Kong in 2000 to that in 2006?
Ensure brevity in your answer.  0.77. What is the ratio of the Taxes (in constant 2015 US$) in Micronesia in 2000 to that in 2006?
Your response must be concise. 0.69. What is the ratio of the Taxes (in constant 2015 US$) in Azerbaijan in 2000 to that in 2007?
Provide a succinct answer. 0.15. What is the ratio of the Taxes (in constant 2015 US$) of Hong Kong in 2000 to that in 2007?
Your answer should be very brief. 0.48. What is the ratio of the Taxes (in constant 2015 US$) in Micronesia in 2000 to that in 2007?
Offer a terse response. 0.72. What is the ratio of the Taxes (in constant 2015 US$) of Timor-Leste in 2000 to that in 2007?
Offer a terse response. 0.56. What is the ratio of the Taxes (in constant 2015 US$) in Azerbaijan in 2001 to that in 2002?
Keep it short and to the point. 0.9. What is the ratio of the Taxes (in constant 2015 US$) of Hong Kong in 2001 to that in 2002?
Offer a very short reply. 1.08. What is the ratio of the Taxes (in constant 2015 US$) in Timor-Leste in 2001 to that in 2002?
Keep it short and to the point. 0.67. What is the ratio of the Taxes (in constant 2015 US$) in Azerbaijan in 2001 to that in 2003?
Keep it short and to the point. 0.8. What is the ratio of the Taxes (in constant 2015 US$) in Hong Kong in 2001 to that in 2003?
Keep it short and to the point. 1.04. What is the ratio of the Taxes (in constant 2015 US$) of Micronesia in 2001 to that in 2003?
Ensure brevity in your answer.  0.81. What is the ratio of the Taxes (in constant 2015 US$) of Timor-Leste in 2001 to that in 2003?
Make the answer very short. 0.53. What is the ratio of the Taxes (in constant 2015 US$) of Azerbaijan in 2001 to that in 2004?
Provide a short and direct response. 0.72. What is the ratio of the Taxes (in constant 2015 US$) of Hong Kong in 2001 to that in 2004?
Give a very brief answer. 0.79. What is the ratio of the Taxes (in constant 2015 US$) of Micronesia in 2001 to that in 2004?
Offer a terse response. 0.76. What is the ratio of the Taxes (in constant 2015 US$) in Timor-Leste in 2001 to that in 2004?
Provide a short and direct response. 0.5. What is the ratio of the Taxes (in constant 2015 US$) of Azerbaijan in 2001 to that in 2005?
Ensure brevity in your answer.  0.45. What is the ratio of the Taxes (in constant 2015 US$) in Hong Kong in 2001 to that in 2005?
Your answer should be very brief. 0.75. What is the ratio of the Taxes (in constant 2015 US$) of Micronesia in 2001 to that in 2005?
Your response must be concise. 0.63. What is the ratio of the Taxes (in constant 2015 US$) of Azerbaijan in 2001 to that in 2006?
Offer a terse response. 0.39. What is the ratio of the Taxes (in constant 2015 US$) of Hong Kong in 2001 to that in 2006?
Keep it short and to the point. 0.65. What is the ratio of the Taxes (in constant 2015 US$) of Micronesia in 2001 to that in 2006?
Make the answer very short. 0.64. What is the ratio of the Taxes (in constant 2015 US$) in Azerbaijan in 2001 to that in 2007?
Provide a succinct answer. 0.21. What is the ratio of the Taxes (in constant 2015 US$) of Hong Kong in 2001 to that in 2007?
Your answer should be compact. 0.41. What is the ratio of the Taxes (in constant 2015 US$) in Micronesia in 2001 to that in 2007?
Your response must be concise. 0.66. What is the ratio of the Taxes (in constant 2015 US$) of Timor-Leste in 2001 to that in 2007?
Make the answer very short. 0.89. What is the ratio of the Taxes (in constant 2015 US$) of Azerbaijan in 2002 to that in 2003?
Your answer should be compact. 0.89. What is the ratio of the Taxes (in constant 2015 US$) of Hong Kong in 2002 to that in 2003?
Your answer should be compact. 0.96. What is the ratio of the Taxes (in constant 2015 US$) in Micronesia in 2002 to that in 2003?
Your answer should be compact. 0.85. What is the ratio of the Taxes (in constant 2015 US$) of Azerbaijan in 2002 to that in 2004?
Provide a short and direct response. 0.8. What is the ratio of the Taxes (in constant 2015 US$) in Hong Kong in 2002 to that in 2004?
Provide a short and direct response. 0.73. What is the ratio of the Taxes (in constant 2015 US$) of Micronesia in 2002 to that in 2004?
Your response must be concise. 0.8. What is the ratio of the Taxes (in constant 2015 US$) of Azerbaijan in 2002 to that in 2005?
Give a very brief answer. 0.5. What is the ratio of the Taxes (in constant 2015 US$) of Hong Kong in 2002 to that in 2005?
Make the answer very short. 0.69. What is the ratio of the Taxes (in constant 2015 US$) in Micronesia in 2002 to that in 2005?
Give a very brief answer. 0.67. What is the ratio of the Taxes (in constant 2015 US$) of Timor-Leste in 2002 to that in 2005?
Give a very brief answer. 1. What is the ratio of the Taxes (in constant 2015 US$) of Azerbaijan in 2002 to that in 2006?
Ensure brevity in your answer.  0.44. What is the ratio of the Taxes (in constant 2015 US$) of Hong Kong in 2002 to that in 2006?
Offer a very short reply. 0.6. What is the ratio of the Taxes (in constant 2015 US$) in Micronesia in 2002 to that in 2006?
Offer a terse response. 0.67. What is the ratio of the Taxes (in constant 2015 US$) of Azerbaijan in 2002 to that in 2007?
Keep it short and to the point. 0.23. What is the ratio of the Taxes (in constant 2015 US$) in Hong Kong in 2002 to that in 2007?
Keep it short and to the point. 0.38. What is the ratio of the Taxes (in constant 2015 US$) in Micronesia in 2002 to that in 2007?
Make the answer very short. 0.7. What is the ratio of the Taxes (in constant 2015 US$) in Timor-Leste in 2002 to that in 2007?
Your response must be concise. 1.33. What is the ratio of the Taxes (in constant 2015 US$) in Azerbaijan in 2003 to that in 2004?
Your answer should be very brief. 0.89. What is the ratio of the Taxes (in constant 2015 US$) in Hong Kong in 2003 to that in 2004?
Offer a very short reply. 0.76. What is the ratio of the Taxes (in constant 2015 US$) of Micronesia in 2003 to that in 2004?
Your answer should be very brief. 0.94. What is the ratio of the Taxes (in constant 2015 US$) in Azerbaijan in 2003 to that in 2005?
Ensure brevity in your answer.  0.56. What is the ratio of the Taxes (in constant 2015 US$) in Hong Kong in 2003 to that in 2005?
Offer a terse response. 0.72. What is the ratio of the Taxes (in constant 2015 US$) of Micronesia in 2003 to that in 2005?
Ensure brevity in your answer.  0.78. What is the ratio of the Taxes (in constant 2015 US$) of Timor-Leste in 2003 to that in 2005?
Ensure brevity in your answer.  1.25. What is the ratio of the Taxes (in constant 2015 US$) in Azerbaijan in 2003 to that in 2006?
Provide a short and direct response. 0.49. What is the ratio of the Taxes (in constant 2015 US$) of Hong Kong in 2003 to that in 2006?
Give a very brief answer. 0.63. What is the ratio of the Taxes (in constant 2015 US$) in Micronesia in 2003 to that in 2006?
Your response must be concise. 0.79. What is the ratio of the Taxes (in constant 2015 US$) of Azerbaijan in 2003 to that in 2007?
Provide a succinct answer. 0.26. What is the ratio of the Taxes (in constant 2015 US$) in Hong Kong in 2003 to that in 2007?
Your answer should be compact. 0.39. What is the ratio of the Taxes (in constant 2015 US$) in Micronesia in 2003 to that in 2007?
Give a very brief answer. 0.82. What is the ratio of the Taxes (in constant 2015 US$) in Timor-Leste in 2003 to that in 2007?
Keep it short and to the point. 1.67. What is the ratio of the Taxes (in constant 2015 US$) of Azerbaijan in 2004 to that in 2005?
Provide a short and direct response. 0.63. What is the ratio of the Taxes (in constant 2015 US$) of Hong Kong in 2004 to that in 2005?
Provide a short and direct response. 0.94. What is the ratio of the Taxes (in constant 2015 US$) in Micronesia in 2004 to that in 2005?
Make the answer very short. 0.83. What is the ratio of the Taxes (in constant 2015 US$) in Timor-Leste in 2004 to that in 2005?
Provide a succinct answer. 1.33. What is the ratio of the Taxes (in constant 2015 US$) in Azerbaijan in 2004 to that in 2006?
Offer a very short reply. 0.55. What is the ratio of the Taxes (in constant 2015 US$) of Hong Kong in 2004 to that in 2006?
Provide a succinct answer. 0.82. What is the ratio of the Taxes (in constant 2015 US$) in Micronesia in 2004 to that in 2006?
Offer a terse response. 0.84. What is the ratio of the Taxes (in constant 2015 US$) of Azerbaijan in 2004 to that in 2007?
Provide a succinct answer. 0.29. What is the ratio of the Taxes (in constant 2015 US$) in Hong Kong in 2004 to that in 2007?
Give a very brief answer. 0.52. What is the ratio of the Taxes (in constant 2015 US$) of Micronesia in 2004 to that in 2007?
Your answer should be compact. 0.87. What is the ratio of the Taxes (in constant 2015 US$) in Timor-Leste in 2004 to that in 2007?
Offer a terse response. 1.78. What is the ratio of the Taxes (in constant 2015 US$) in Azerbaijan in 2005 to that in 2006?
Make the answer very short. 0.87. What is the ratio of the Taxes (in constant 2015 US$) in Hong Kong in 2005 to that in 2006?
Your answer should be very brief. 0.87. What is the ratio of the Taxes (in constant 2015 US$) in Micronesia in 2005 to that in 2006?
Make the answer very short. 1.01. What is the ratio of the Taxes (in constant 2015 US$) of Azerbaijan in 2005 to that in 2007?
Ensure brevity in your answer.  0.46. What is the ratio of the Taxes (in constant 2015 US$) of Hong Kong in 2005 to that in 2007?
Your answer should be very brief. 0.55. What is the ratio of the Taxes (in constant 2015 US$) of Micronesia in 2005 to that in 2007?
Keep it short and to the point. 1.05. What is the ratio of the Taxes (in constant 2015 US$) in Timor-Leste in 2005 to that in 2007?
Provide a succinct answer. 1.33. What is the ratio of the Taxes (in constant 2015 US$) in Azerbaijan in 2006 to that in 2007?
Give a very brief answer. 0.53. What is the ratio of the Taxes (in constant 2015 US$) in Hong Kong in 2006 to that in 2007?
Your answer should be compact. 0.63. What is the ratio of the Taxes (in constant 2015 US$) in Micronesia in 2006 to that in 2007?
Give a very brief answer. 1.03. What is the difference between the highest and the second highest Taxes (in constant 2015 US$) of Azerbaijan?
Your answer should be very brief. 1.03e+09. What is the difference between the highest and the second highest Taxes (in constant 2015 US$) of Hong Kong?
Provide a short and direct response. 3.09e+09. What is the difference between the highest and the second highest Taxes (in constant 2015 US$) in Micronesia?
Your answer should be very brief. 2.57e+05. What is the difference between the highest and the lowest Taxes (in constant 2015 US$) of Azerbaijan?
Make the answer very short. 1.85e+09. What is the difference between the highest and the lowest Taxes (in constant 2015 US$) in Hong Kong?
Make the answer very short. 5.16e+09. What is the difference between the highest and the lowest Taxes (in constant 2015 US$) in Micronesia?
Give a very brief answer. 7.88e+06. What is the difference between the highest and the lowest Taxes (in constant 2015 US$) in Timor-Leste?
Offer a terse response. 1.60e+07. 